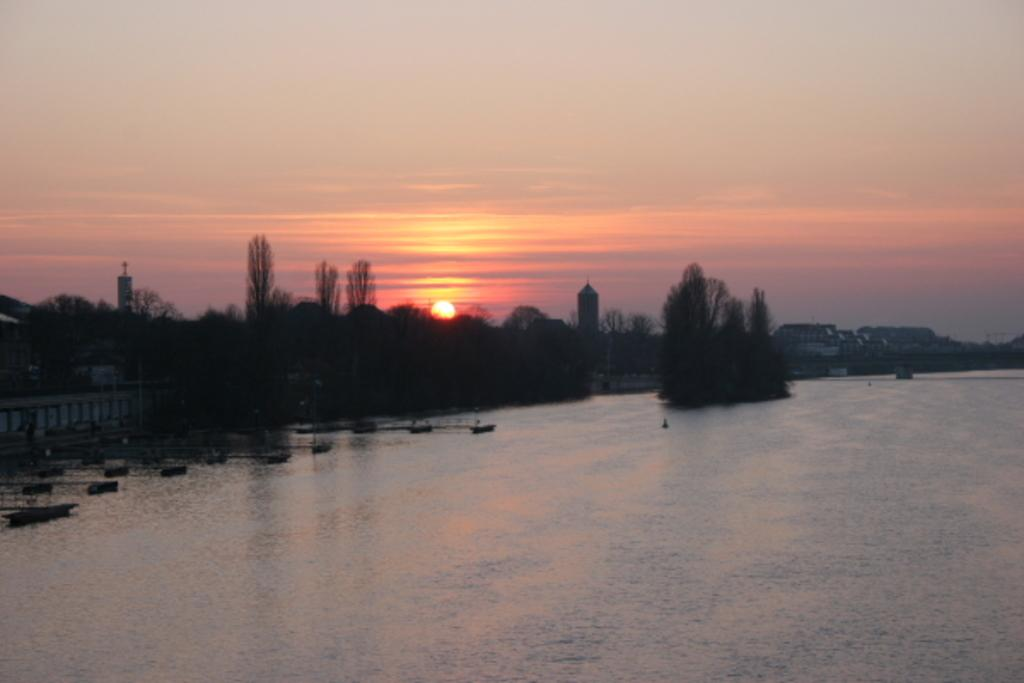What natural element can be seen in the image? Water is visible in the image. What type of vegetation is present in the image? There are trees in the image. What type of man-made structures can be seen in the image? There are buildings in the image. What celestial body is visible in the image? The sun is visible in the image. What is visible in the background of the image? The sky is visible in the background of the image. Can you tell me how many scales are present on the tiger in the image? There is no tiger present in the image, so it is not possible to determine the number of scales on it. What type of hall is visible in the image? There is no hall present in the image; it features water, trees, buildings, the sun, and the sky. 